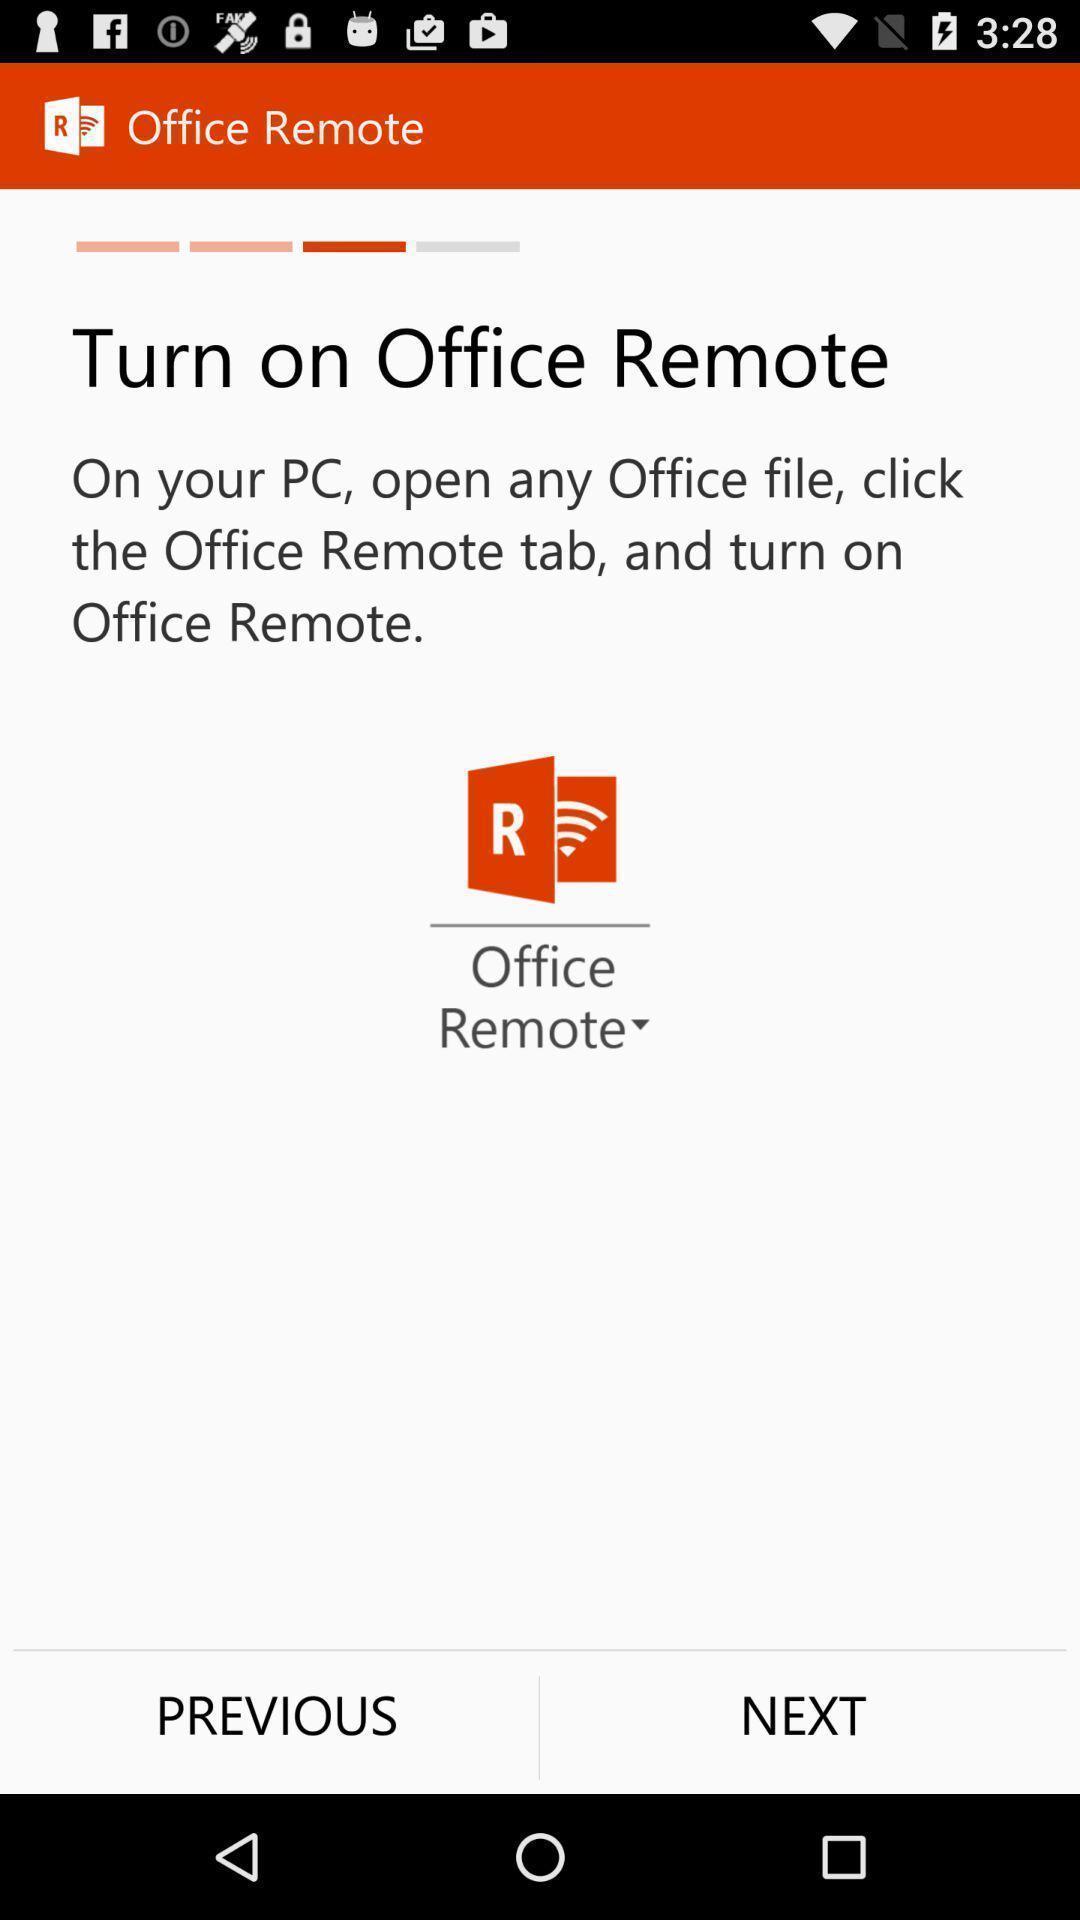Summarize the information in this screenshot. Page displaying the turn on office remote. 